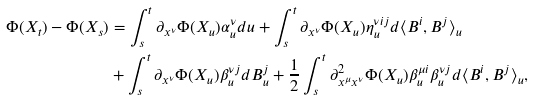Convert formula to latex. <formula><loc_0><loc_0><loc_500><loc_500>\Phi ( X _ { t } ) - \Phi ( X _ { s } ) & = \int ^ { t } _ { s } \partial _ { x ^ { \nu } } \Phi ( X _ { u } ) \alpha ^ { \nu } _ { u } d u + \int ^ { t } _ { s } \partial _ { x ^ { \nu } } \Phi ( X _ { u } ) \eta ^ { \nu i j } _ { u } d \langle B ^ { i } , B ^ { j } \rangle _ { u } \\ & + \int ^ { t } _ { s } \partial _ { x ^ { \nu } } \Phi ( X _ { u } ) \beta ^ { \nu j } _ { u } d B ^ { j } _ { u } + \frac { 1 } { 2 } \int ^ { t } _ { s } \partial ^ { 2 } _ { x ^ { \mu } x ^ { \nu } } \Phi ( X _ { u } ) \beta ^ { \mu i } _ { u } \beta ^ { \nu j } _ { u } d \langle B ^ { i } , B ^ { j } \rangle _ { u } ,</formula> 